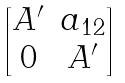Convert formula to latex. <formula><loc_0><loc_0><loc_500><loc_500>\begin{bmatrix} A ^ { \prime } & a _ { 1 2 } \\ 0 & A ^ { \prime } \end{bmatrix}</formula> 